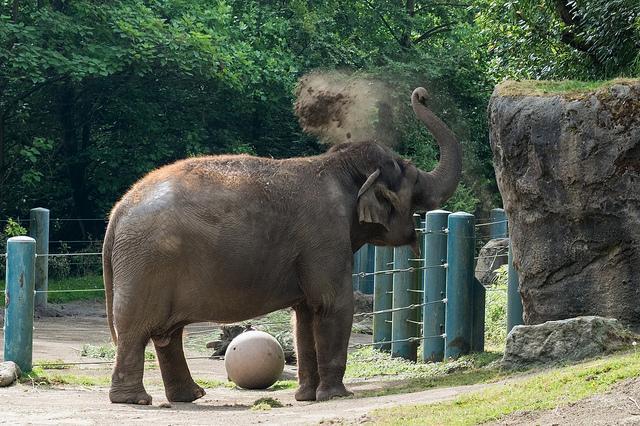How many sports balls can be seen?
Give a very brief answer. 1. 